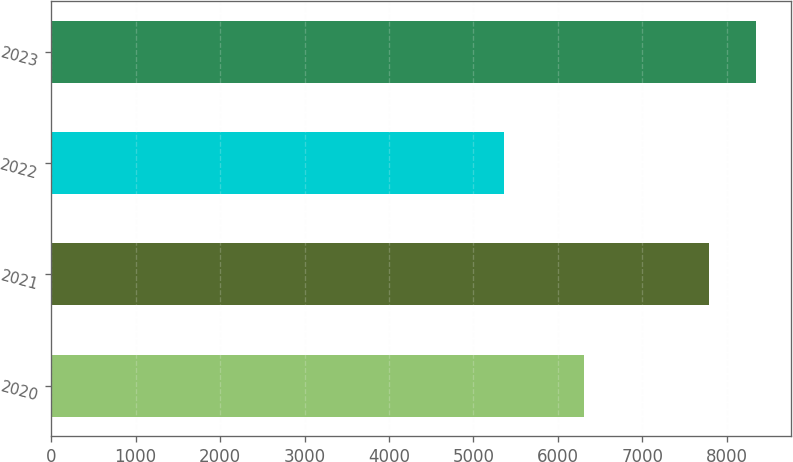Convert chart. <chart><loc_0><loc_0><loc_500><loc_500><bar_chart><fcel>2020<fcel>2021<fcel>2022<fcel>2023<nl><fcel>6308<fcel>7790<fcel>5365<fcel>8343<nl></chart> 